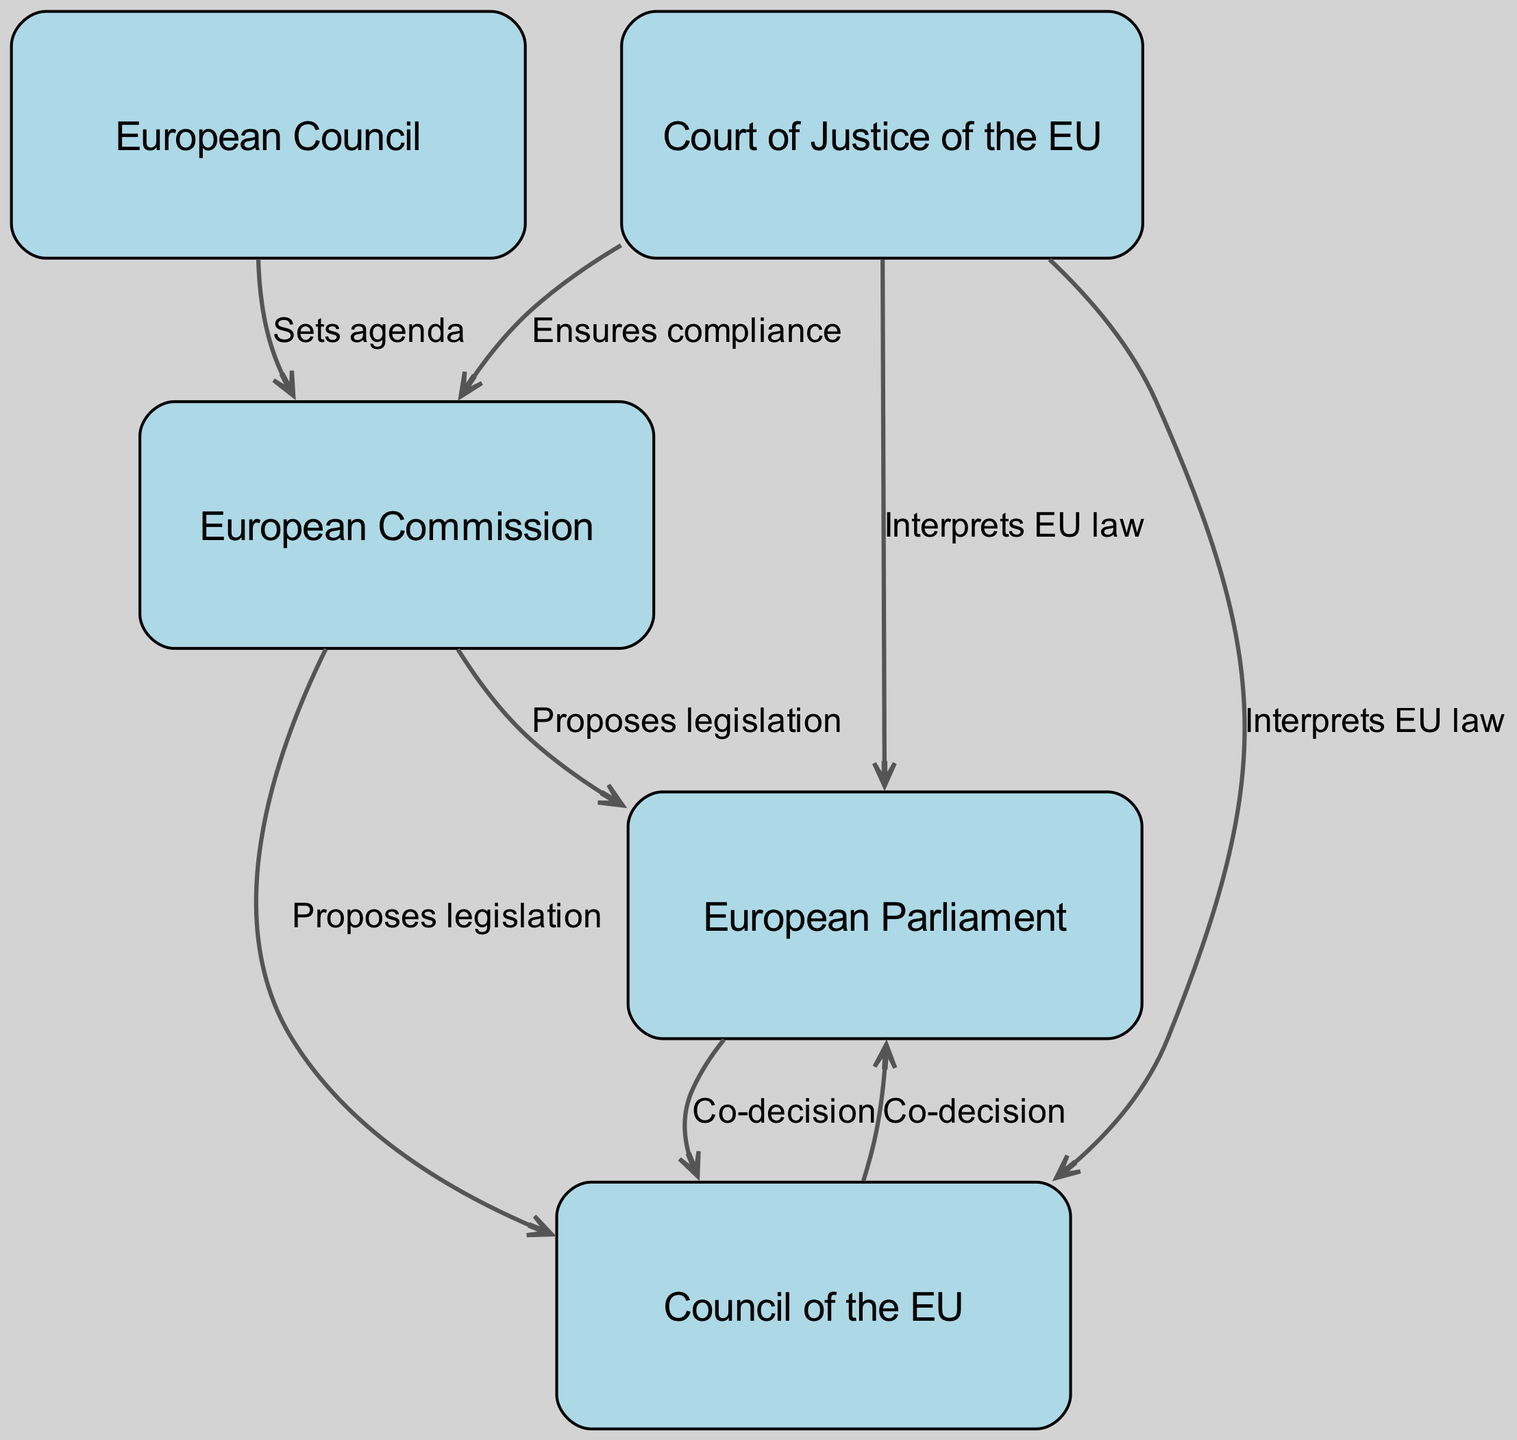What institution sets the agenda in the EU decision-making process? According to the diagram, the European Council is indicated as setting the agenda. This is shown by the direct edge from the European Council node to the European Commission node, labeled "Sets agenda".
Answer: European Council How many nodes are present in the diagram? The diagram lists a total of five nodes that represent different institutions involved in the EU decision-making process: the European Council, European Commission, European Parliament, Council of the EU, and Court of Justice of the EU. Therefore, counting these gives a total of five nodes.
Answer: 5 Which institution proposes legislation to the Council of the EU? The diagram illustrates that the European Commission proposes legislation to the Council of the EU. This is evident from the edge labeled "Proposes legislation" connecting the European Commission node to the Council of the EU node.
Answer: European Commission What is the nature of the relationship between the European Parliament and the Council of the EU? The diagram indicates that the European Parliament and the Council of the EU have a co-decision relationship. This is represented by two edges, one going from the European Parliament to the Council of the EU and one returning from the Council of the EU to the European Parliament, both labeled "Co-decision".
Answer: Co-decision Which institution ensures compliance with EU law? The diagram specifies that the Court of Justice of the EU ensures compliance with EU law. This can be deduced from the edges shown from the Court of Justice node to both the European Commission and the European Parliament, indicating its role in legal compliance and interpretation.
Answer: Court of Justice of the EU What does the Court of Justice of the EU do in relation to the European Commission? The diagram shows that the Court of Justice of the EU ensures compliance with EU law as it relates to the European Commission. An edge labeled "Ensures compliance" connects these two institutions, indicating the Court's role in oversight.
Answer: Ensures compliance 